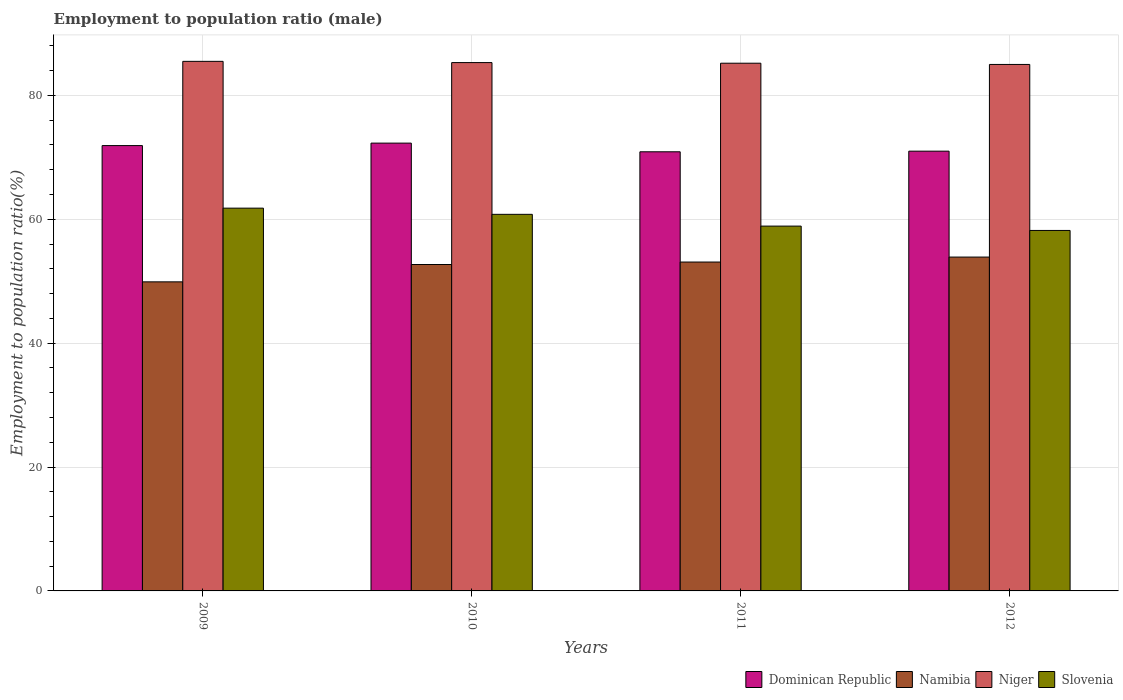How many different coloured bars are there?
Make the answer very short. 4. How many groups of bars are there?
Keep it short and to the point. 4. Are the number of bars per tick equal to the number of legend labels?
Give a very brief answer. Yes. How many bars are there on the 3rd tick from the left?
Your answer should be compact. 4. How many bars are there on the 3rd tick from the right?
Offer a very short reply. 4. What is the label of the 1st group of bars from the left?
Offer a very short reply. 2009. In how many cases, is the number of bars for a given year not equal to the number of legend labels?
Provide a succinct answer. 0. What is the employment to population ratio in Niger in 2012?
Ensure brevity in your answer.  85. Across all years, what is the maximum employment to population ratio in Niger?
Offer a terse response. 85.5. Across all years, what is the minimum employment to population ratio in Dominican Republic?
Your response must be concise. 70.9. What is the total employment to population ratio in Dominican Republic in the graph?
Your answer should be compact. 286.1. What is the difference between the employment to population ratio in Namibia in 2010 and that in 2012?
Your response must be concise. -1.2. What is the difference between the employment to population ratio in Slovenia in 2010 and the employment to population ratio in Niger in 2009?
Offer a very short reply. -24.7. What is the average employment to population ratio in Namibia per year?
Your answer should be very brief. 52.4. In the year 2010, what is the difference between the employment to population ratio in Slovenia and employment to population ratio in Dominican Republic?
Offer a terse response. -11.5. In how many years, is the employment to population ratio in Namibia greater than 80 %?
Your answer should be compact. 0. What is the ratio of the employment to population ratio in Dominican Republic in 2010 to that in 2012?
Provide a short and direct response. 1.02. Is the difference between the employment to population ratio in Slovenia in 2009 and 2010 greater than the difference between the employment to population ratio in Dominican Republic in 2009 and 2010?
Provide a short and direct response. Yes. What is the difference between the highest and the second highest employment to population ratio in Niger?
Your answer should be compact. 0.2. Is the sum of the employment to population ratio in Namibia in 2010 and 2011 greater than the maximum employment to population ratio in Niger across all years?
Ensure brevity in your answer.  Yes. What does the 3rd bar from the left in 2012 represents?
Your response must be concise. Niger. What does the 2nd bar from the right in 2009 represents?
Provide a short and direct response. Niger. Is it the case that in every year, the sum of the employment to population ratio in Dominican Republic and employment to population ratio in Niger is greater than the employment to population ratio in Slovenia?
Provide a succinct answer. Yes. How many years are there in the graph?
Provide a succinct answer. 4. What is the difference between two consecutive major ticks on the Y-axis?
Ensure brevity in your answer.  20. Where does the legend appear in the graph?
Keep it short and to the point. Bottom right. How are the legend labels stacked?
Keep it short and to the point. Horizontal. What is the title of the graph?
Offer a terse response. Employment to population ratio (male). What is the label or title of the X-axis?
Your answer should be very brief. Years. What is the label or title of the Y-axis?
Provide a short and direct response. Employment to population ratio(%). What is the Employment to population ratio(%) of Dominican Republic in 2009?
Provide a short and direct response. 71.9. What is the Employment to population ratio(%) of Namibia in 2009?
Your response must be concise. 49.9. What is the Employment to population ratio(%) of Niger in 2009?
Provide a short and direct response. 85.5. What is the Employment to population ratio(%) of Slovenia in 2009?
Provide a short and direct response. 61.8. What is the Employment to population ratio(%) of Dominican Republic in 2010?
Provide a short and direct response. 72.3. What is the Employment to population ratio(%) of Namibia in 2010?
Provide a short and direct response. 52.7. What is the Employment to population ratio(%) of Niger in 2010?
Give a very brief answer. 85.3. What is the Employment to population ratio(%) in Slovenia in 2010?
Give a very brief answer. 60.8. What is the Employment to population ratio(%) in Dominican Republic in 2011?
Offer a very short reply. 70.9. What is the Employment to population ratio(%) in Namibia in 2011?
Keep it short and to the point. 53.1. What is the Employment to population ratio(%) in Niger in 2011?
Keep it short and to the point. 85.2. What is the Employment to population ratio(%) of Slovenia in 2011?
Give a very brief answer. 58.9. What is the Employment to population ratio(%) of Namibia in 2012?
Provide a succinct answer. 53.9. What is the Employment to population ratio(%) in Niger in 2012?
Offer a terse response. 85. What is the Employment to population ratio(%) in Slovenia in 2012?
Your answer should be compact. 58.2. Across all years, what is the maximum Employment to population ratio(%) in Dominican Republic?
Make the answer very short. 72.3. Across all years, what is the maximum Employment to population ratio(%) of Namibia?
Offer a terse response. 53.9. Across all years, what is the maximum Employment to population ratio(%) of Niger?
Give a very brief answer. 85.5. Across all years, what is the maximum Employment to population ratio(%) of Slovenia?
Provide a succinct answer. 61.8. Across all years, what is the minimum Employment to population ratio(%) of Dominican Republic?
Provide a succinct answer. 70.9. Across all years, what is the minimum Employment to population ratio(%) of Namibia?
Offer a very short reply. 49.9. Across all years, what is the minimum Employment to population ratio(%) of Slovenia?
Make the answer very short. 58.2. What is the total Employment to population ratio(%) of Dominican Republic in the graph?
Provide a short and direct response. 286.1. What is the total Employment to population ratio(%) in Namibia in the graph?
Your answer should be very brief. 209.6. What is the total Employment to population ratio(%) of Niger in the graph?
Your answer should be very brief. 341. What is the total Employment to population ratio(%) in Slovenia in the graph?
Offer a terse response. 239.7. What is the difference between the Employment to population ratio(%) of Niger in 2009 and that in 2010?
Make the answer very short. 0.2. What is the difference between the Employment to population ratio(%) of Dominican Republic in 2009 and that in 2011?
Make the answer very short. 1. What is the difference between the Employment to population ratio(%) in Namibia in 2009 and that in 2011?
Your answer should be compact. -3.2. What is the difference between the Employment to population ratio(%) in Slovenia in 2009 and that in 2011?
Your answer should be very brief. 2.9. What is the difference between the Employment to population ratio(%) of Dominican Republic in 2009 and that in 2012?
Provide a succinct answer. 0.9. What is the difference between the Employment to population ratio(%) in Niger in 2009 and that in 2012?
Offer a terse response. 0.5. What is the difference between the Employment to population ratio(%) of Slovenia in 2009 and that in 2012?
Provide a succinct answer. 3.6. What is the difference between the Employment to population ratio(%) of Namibia in 2010 and that in 2011?
Provide a succinct answer. -0.4. What is the difference between the Employment to population ratio(%) in Niger in 2010 and that in 2012?
Give a very brief answer. 0.3. What is the difference between the Employment to population ratio(%) in Dominican Republic in 2011 and that in 2012?
Your answer should be compact. -0.1. What is the difference between the Employment to population ratio(%) of Niger in 2011 and that in 2012?
Your response must be concise. 0.2. What is the difference between the Employment to population ratio(%) in Dominican Republic in 2009 and the Employment to population ratio(%) in Namibia in 2010?
Ensure brevity in your answer.  19.2. What is the difference between the Employment to population ratio(%) of Dominican Republic in 2009 and the Employment to population ratio(%) of Niger in 2010?
Your response must be concise. -13.4. What is the difference between the Employment to population ratio(%) in Namibia in 2009 and the Employment to population ratio(%) in Niger in 2010?
Give a very brief answer. -35.4. What is the difference between the Employment to population ratio(%) in Niger in 2009 and the Employment to population ratio(%) in Slovenia in 2010?
Offer a terse response. 24.7. What is the difference between the Employment to population ratio(%) of Dominican Republic in 2009 and the Employment to population ratio(%) of Niger in 2011?
Your response must be concise. -13.3. What is the difference between the Employment to population ratio(%) in Dominican Republic in 2009 and the Employment to population ratio(%) in Slovenia in 2011?
Make the answer very short. 13. What is the difference between the Employment to population ratio(%) of Namibia in 2009 and the Employment to population ratio(%) of Niger in 2011?
Offer a terse response. -35.3. What is the difference between the Employment to population ratio(%) of Niger in 2009 and the Employment to population ratio(%) of Slovenia in 2011?
Your answer should be compact. 26.6. What is the difference between the Employment to population ratio(%) in Dominican Republic in 2009 and the Employment to population ratio(%) in Namibia in 2012?
Your answer should be compact. 18. What is the difference between the Employment to population ratio(%) in Dominican Republic in 2009 and the Employment to population ratio(%) in Slovenia in 2012?
Keep it short and to the point. 13.7. What is the difference between the Employment to population ratio(%) in Namibia in 2009 and the Employment to population ratio(%) in Niger in 2012?
Provide a short and direct response. -35.1. What is the difference between the Employment to population ratio(%) of Namibia in 2009 and the Employment to population ratio(%) of Slovenia in 2012?
Give a very brief answer. -8.3. What is the difference between the Employment to population ratio(%) of Niger in 2009 and the Employment to population ratio(%) of Slovenia in 2012?
Your response must be concise. 27.3. What is the difference between the Employment to population ratio(%) in Dominican Republic in 2010 and the Employment to population ratio(%) in Niger in 2011?
Offer a very short reply. -12.9. What is the difference between the Employment to population ratio(%) in Namibia in 2010 and the Employment to population ratio(%) in Niger in 2011?
Your response must be concise. -32.5. What is the difference between the Employment to population ratio(%) in Niger in 2010 and the Employment to population ratio(%) in Slovenia in 2011?
Offer a very short reply. 26.4. What is the difference between the Employment to population ratio(%) of Dominican Republic in 2010 and the Employment to population ratio(%) of Namibia in 2012?
Offer a terse response. 18.4. What is the difference between the Employment to population ratio(%) in Dominican Republic in 2010 and the Employment to population ratio(%) in Niger in 2012?
Offer a very short reply. -12.7. What is the difference between the Employment to population ratio(%) of Dominican Republic in 2010 and the Employment to population ratio(%) of Slovenia in 2012?
Your answer should be compact. 14.1. What is the difference between the Employment to population ratio(%) in Namibia in 2010 and the Employment to population ratio(%) in Niger in 2012?
Your answer should be compact. -32.3. What is the difference between the Employment to population ratio(%) in Niger in 2010 and the Employment to population ratio(%) in Slovenia in 2012?
Provide a short and direct response. 27.1. What is the difference between the Employment to population ratio(%) in Dominican Republic in 2011 and the Employment to population ratio(%) in Namibia in 2012?
Your answer should be very brief. 17. What is the difference between the Employment to population ratio(%) of Dominican Republic in 2011 and the Employment to population ratio(%) of Niger in 2012?
Provide a short and direct response. -14.1. What is the difference between the Employment to population ratio(%) of Dominican Republic in 2011 and the Employment to population ratio(%) of Slovenia in 2012?
Offer a terse response. 12.7. What is the difference between the Employment to population ratio(%) of Namibia in 2011 and the Employment to population ratio(%) of Niger in 2012?
Keep it short and to the point. -31.9. What is the average Employment to population ratio(%) of Dominican Republic per year?
Offer a very short reply. 71.53. What is the average Employment to population ratio(%) of Namibia per year?
Keep it short and to the point. 52.4. What is the average Employment to population ratio(%) in Niger per year?
Offer a very short reply. 85.25. What is the average Employment to population ratio(%) in Slovenia per year?
Keep it short and to the point. 59.92. In the year 2009, what is the difference between the Employment to population ratio(%) in Dominican Republic and Employment to population ratio(%) in Namibia?
Your response must be concise. 22. In the year 2009, what is the difference between the Employment to population ratio(%) in Dominican Republic and Employment to population ratio(%) in Niger?
Your response must be concise. -13.6. In the year 2009, what is the difference between the Employment to population ratio(%) of Namibia and Employment to population ratio(%) of Niger?
Provide a short and direct response. -35.6. In the year 2009, what is the difference between the Employment to population ratio(%) of Namibia and Employment to population ratio(%) of Slovenia?
Your answer should be compact. -11.9. In the year 2009, what is the difference between the Employment to population ratio(%) of Niger and Employment to population ratio(%) of Slovenia?
Make the answer very short. 23.7. In the year 2010, what is the difference between the Employment to population ratio(%) of Dominican Republic and Employment to population ratio(%) of Namibia?
Offer a very short reply. 19.6. In the year 2010, what is the difference between the Employment to population ratio(%) in Dominican Republic and Employment to population ratio(%) in Niger?
Keep it short and to the point. -13. In the year 2010, what is the difference between the Employment to population ratio(%) in Namibia and Employment to population ratio(%) in Niger?
Give a very brief answer. -32.6. In the year 2010, what is the difference between the Employment to population ratio(%) in Niger and Employment to population ratio(%) in Slovenia?
Your answer should be compact. 24.5. In the year 2011, what is the difference between the Employment to population ratio(%) of Dominican Republic and Employment to population ratio(%) of Niger?
Make the answer very short. -14.3. In the year 2011, what is the difference between the Employment to population ratio(%) of Namibia and Employment to population ratio(%) of Niger?
Offer a terse response. -32.1. In the year 2011, what is the difference between the Employment to population ratio(%) in Namibia and Employment to population ratio(%) in Slovenia?
Your response must be concise. -5.8. In the year 2011, what is the difference between the Employment to population ratio(%) in Niger and Employment to population ratio(%) in Slovenia?
Provide a short and direct response. 26.3. In the year 2012, what is the difference between the Employment to population ratio(%) in Dominican Republic and Employment to population ratio(%) in Niger?
Your answer should be very brief. -14. In the year 2012, what is the difference between the Employment to population ratio(%) in Dominican Republic and Employment to population ratio(%) in Slovenia?
Your answer should be very brief. 12.8. In the year 2012, what is the difference between the Employment to population ratio(%) of Namibia and Employment to population ratio(%) of Niger?
Your answer should be very brief. -31.1. In the year 2012, what is the difference between the Employment to population ratio(%) in Namibia and Employment to population ratio(%) in Slovenia?
Your answer should be very brief. -4.3. In the year 2012, what is the difference between the Employment to population ratio(%) of Niger and Employment to population ratio(%) of Slovenia?
Make the answer very short. 26.8. What is the ratio of the Employment to population ratio(%) of Dominican Republic in 2009 to that in 2010?
Offer a terse response. 0.99. What is the ratio of the Employment to population ratio(%) in Namibia in 2009 to that in 2010?
Your response must be concise. 0.95. What is the ratio of the Employment to population ratio(%) of Slovenia in 2009 to that in 2010?
Your answer should be very brief. 1.02. What is the ratio of the Employment to population ratio(%) of Dominican Republic in 2009 to that in 2011?
Keep it short and to the point. 1.01. What is the ratio of the Employment to population ratio(%) in Namibia in 2009 to that in 2011?
Make the answer very short. 0.94. What is the ratio of the Employment to population ratio(%) in Slovenia in 2009 to that in 2011?
Offer a terse response. 1.05. What is the ratio of the Employment to population ratio(%) of Dominican Republic in 2009 to that in 2012?
Provide a succinct answer. 1.01. What is the ratio of the Employment to population ratio(%) in Namibia in 2009 to that in 2012?
Your response must be concise. 0.93. What is the ratio of the Employment to population ratio(%) of Niger in 2009 to that in 2012?
Your answer should be compact. 1.01. What is the ratio of the Employment to population ratio(%) of Slovenia in 2009 to that in 2012?
Your answer should be compact. 1.06. What is the ratio of the Employment to population ratio(%) in Dominican Republic in 2010 to that in 2011?
Your answer should be compact. 1.02. What is the ratio of the Employment to population ratio(%) of Niger in 2010 to that in 2011?
Your answer should be very brief. 1. What is the ratio of the Employment to population ratio(%) of Slovenia in 2010 to that in 2011?
Offer a very short reply. 1.03. What is the ratio of the Employment to population ratio(%) in Dominican Republic in 2010 to that in 2012?
Keep it short and to the point. 1.02. What is the ratio of the Employment to population ratio(%) of Namibia in 2010 to that in 2012?
Give a very brief answer. 0.98. What is the ratio of the Employment to population ratio(%) of Niger in 2010 to that in 2012?
Give a very brief answer. 1. What is the ratio of the Employment to population ratio(%) in Slovenia in 2010 to that in 2012?
Keep it short and to the point. 1.04. What is the ratio of the Employment to population ratio(%) of Dominican Republic in 2011 to that in 2012?
Offer a very short reply. 1. What is the ratio of the Employment to population ratio(%) of Namibia in 2011 to that in 2012?
Offer a terse response. 0.99. What is the ratio of the Employment to population ratio(%) of Niger in 2011 to that in 2012?
Your response must be concise. 1. What is the difference between the highest and the lowest Employment to population ratio(%) in Slovenia?
Provide a short and direct response. 3.6. 